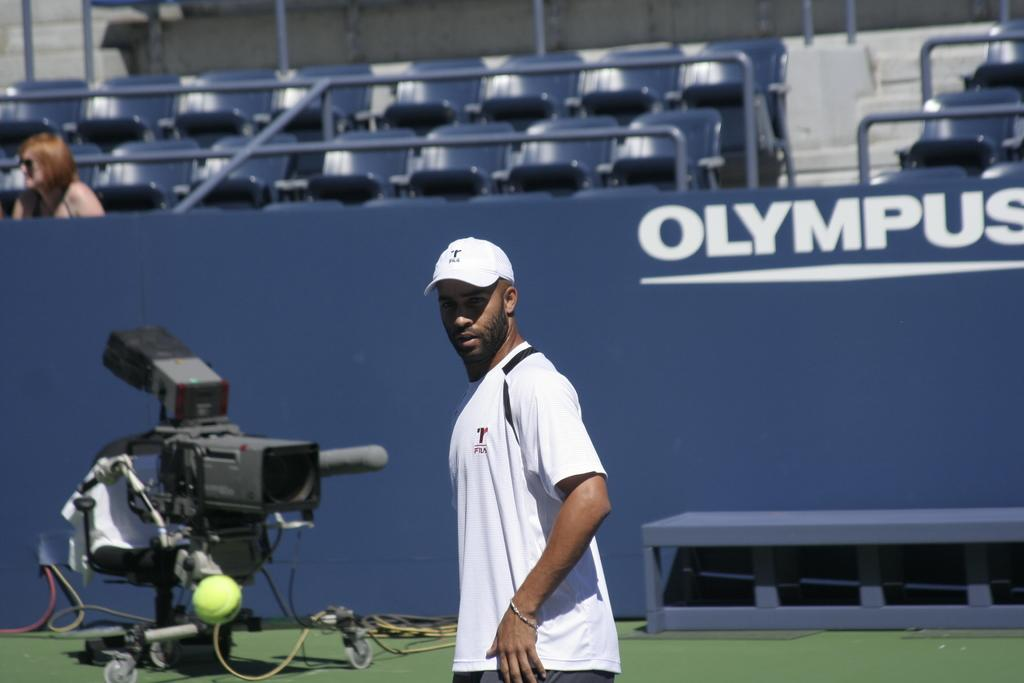<image>
Render a clear and concise summary of the photo. A tennis player stands in front of a banner for olympus. 